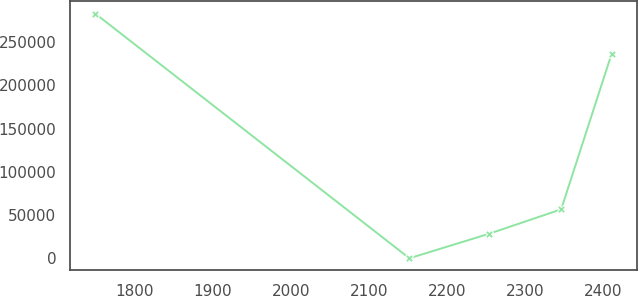Convert chart to OTSL. <chart><loc_0><loc_0><loc_500><loc_500><line_chart><ecel><fcel>Unnamed: 1<nl><fcel>1749.21<fcel>282905<nl><fcel>2151.89<fcel>180.84<nl><fcel>2253.89<fcel>28453.3<nl><fcel>2346.47<fcel>56725.7<nl><fcel>2411.01<fcel>236083<nl></chart> 